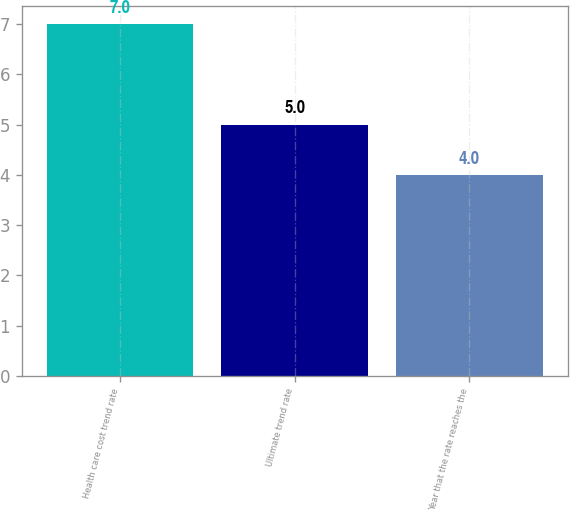<chart> <loc_0><loc_0><loc_500><loc_500><bar_chart><fcel>Health care cost trend rate<fcel>Ultimate trend rate<fcel>Year that the rate reaches the<nl><fcel>7<fcel>5<fcel>4<nl></chart> 